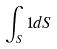<formula> <loc_0><loc_0><loc_500><loc_500>\int _ { S } 1 d S</formula> 